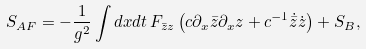Convert formula to latex. <formula><loc_0><loc_0><loc_500><loc_500>S _ { A F } = - \frac { 1 } { g ^ { 2 } } \int d x d t \, F _ { \bar { z } z } \left ( c \partial _ { x } \bar { z } \partial _ { x } z + c ^ { - 1 } \dot { \bar { z } } \dot { z } \right ) + S _ { B } ,</formula> 